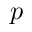Convert formula to latex. <formula><loc_0><loc_0><loc_500><loc_500>p</formula> 